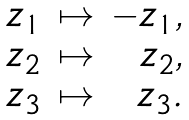Convert formula to latex. <formula><loc_0><loc_0><loc_500><loc_500>\begin{array} { r r r } z _ { 1 } & \mapsto & - z _ { 1 } , \\ z _ { 2 } & \mapsto & z _ { 2 } , \\ z _ { 3 } & \mapsto & z _ { 3 } . \end{array}</formula> 